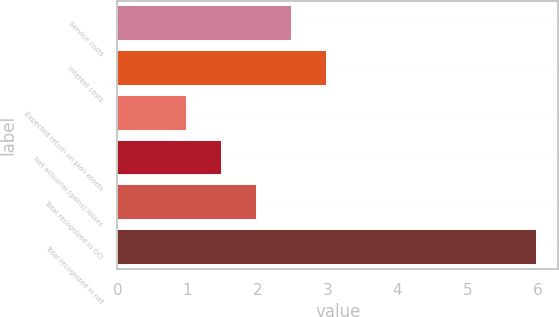<chart> <loc_0><loc_0><loc_500><loc_500><bar_chart><fcel>Service costs<fcel>Interest costs<fcel>Expected return on plan assets<fcel>Net actuarial (gains) losses<fcel>Total recognized in OCI<fcel>Total recognized in net<nl><fcel>2.5<fcel>3<fcel>1<fcel>1.5<fcel>2<fcel>6<nl></chart> 